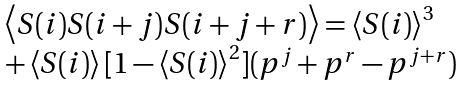Convert formula to latex. <formula><loc_0><loc_0><loc_500><loc_500>\begin{array} { l } \left \langle S ( i ) S ( i + j ) S ( i + j + r ) \right \rangle = \left \langle S ( i ) \right \rangle ^ { 3 } \\ + \left \langle S ( i ) \right \rangle [ 1 - \left \langle S ( i ) \right \rangle ^ { 2 } ] ( p ^ { j } + p ^ { r } - p ^ { j + r } ) \end{array}</formula> 